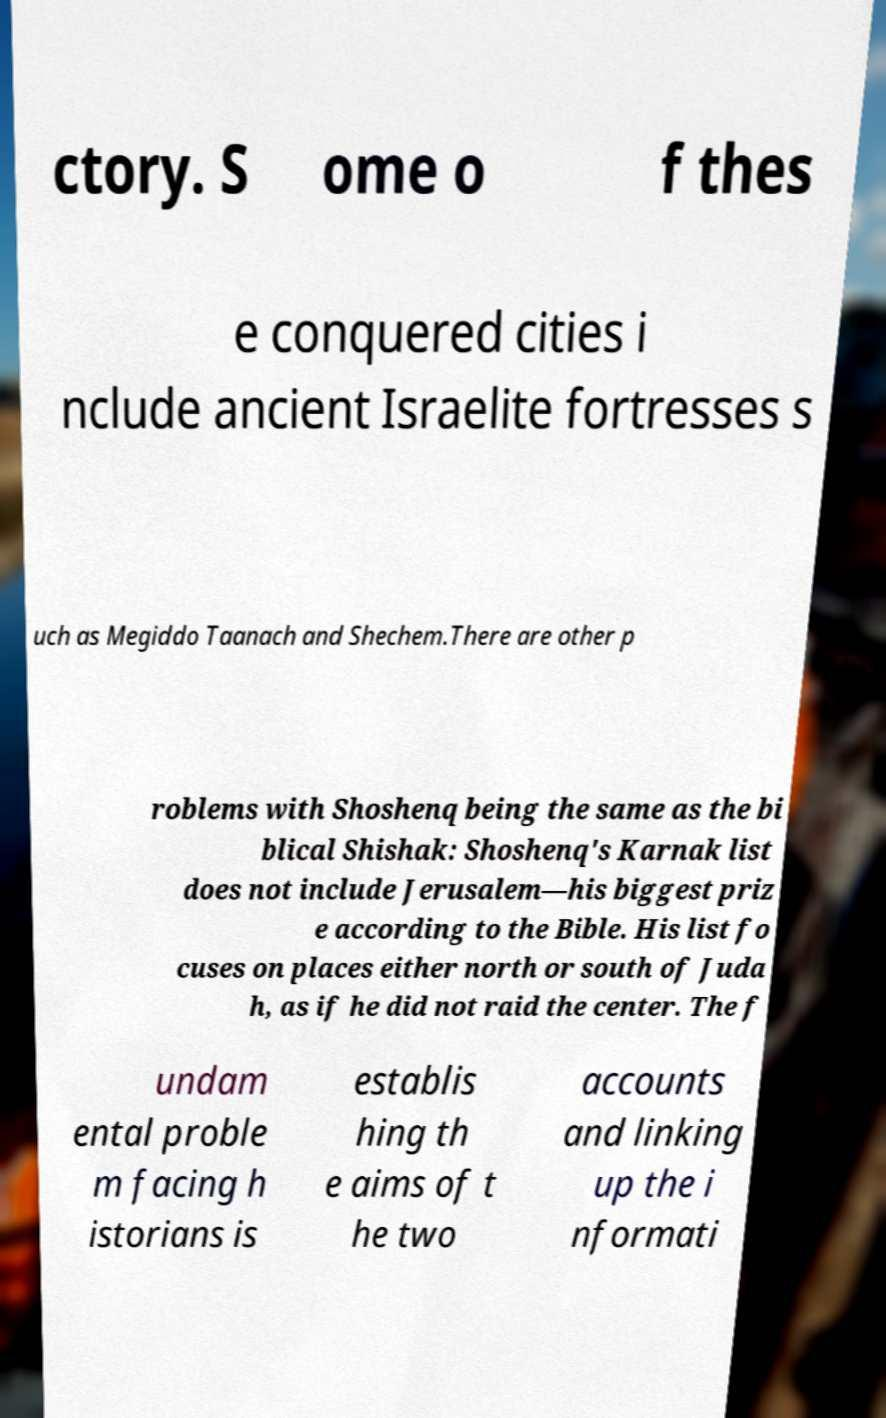Can you read and provide the text displayed in the image?This photo seems to have some interesting text. Can you extract and type it out for me? ctory. S ome o f thes e conquered cities i nclude ancient Israelite fortresses s uch as Megiddo Taanach and Shechem.There are other p roblems with Shoshenq being the same as the bi blical Shishak: Shoshenq's Karnak list does not include Jerusalem—his biggest priz e according to the Bible. His list fo cuses on places either north or south of Juda h, as if he did not raid the center. The f undam ental proble m facing h istorians is establis hing th e aims of t he two accounts and linking up the i nformati 